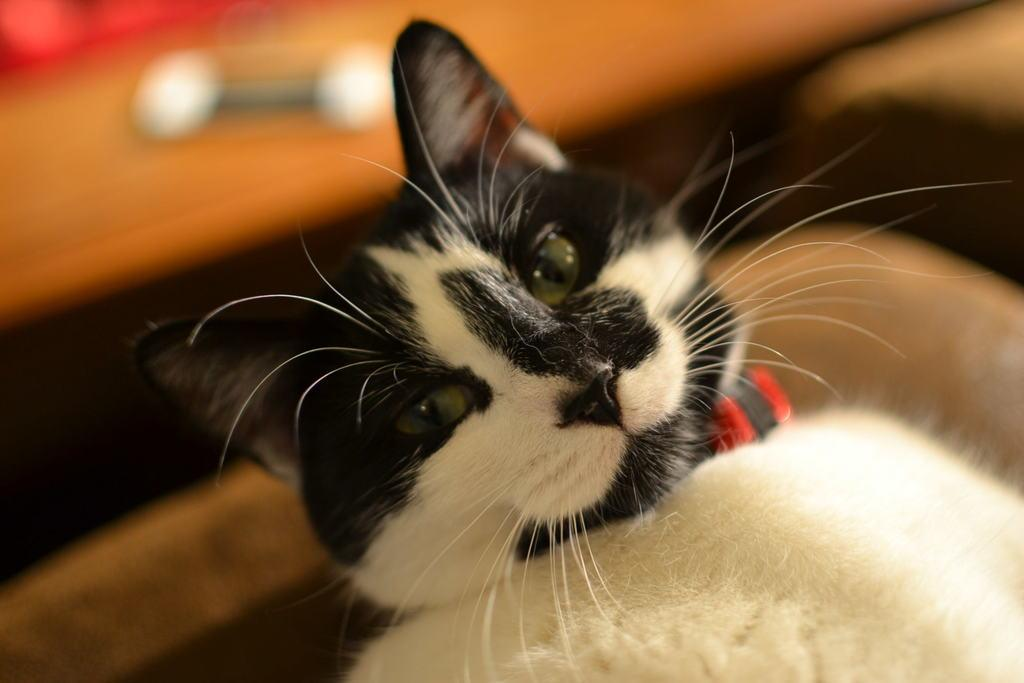What type of animal is in the image? There is a black and white cat in the image. Can you describe the background of the image? The background of the image is blurred. What type of page can be seen in the image? There is no page present in the image; it features a black and white cat and a blurred background. What kind of pipe is visible in the image? There is no pipe present in the image. Can you describe the vase in the image? There is no vase present in the image. 